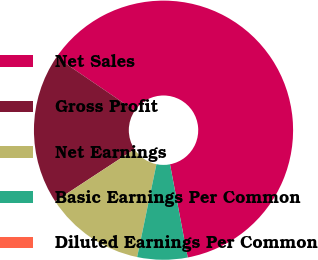Convert chart. <chart><loc_0><loc_0><loc_500><loc_500><pie_chart><fcel>Net Sales<fcel>Gross Profit<fcel>Net Earnings<fcel>Basic Earnings Per Common<fcel>Diluted Earnings Per Common<nl><fcel>62.49%<fcel>18.75%<fcel>12.5%<fcel>6.25%<fcel>0.0%<nl></chart> 